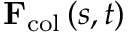Convert formula to latex. <formula><loc_0><loc_0><loc_500><loc_500>{ F } _ { c o l } \left ( s , t \right )</formula> 